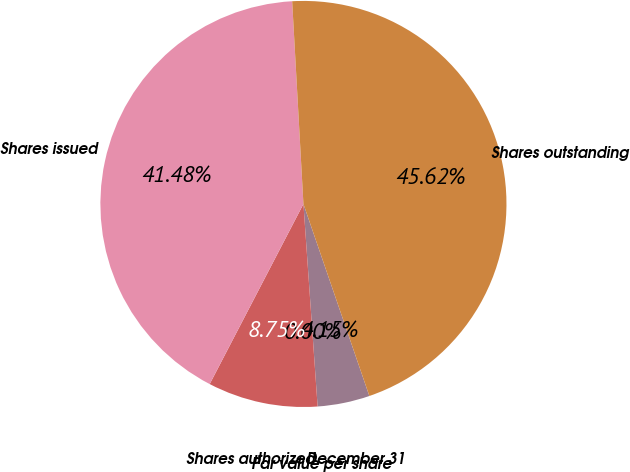<chart> <loc_0><loc_0><loc_500><loc_500><pie_chart><fcel>December 31<fcel>Par value per share<fcel>Shares authorized<fcel>Shares issued<fcel>Shares outstanding<nl><fcel>4.15%<fcel>0.0%<fcel>8.75%<fcel>41.48%<fcel>45.62%<nl></chart> 